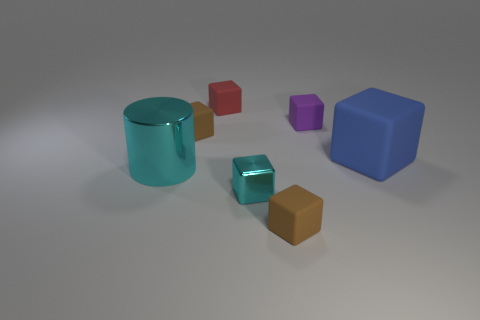How many tiny cyan things are made of the same material as the big cyan thing?
Your response must be concise. 1. Does the big block have the same color as the small rubber block in front of the large metallic object?
Give a very brief answer. No. Are there more big cyan metallic things than blocks?
Your answer should be compact. No. The big cube has what color?
Your answer should be very brief. Blue. There is a big thing that is left of the purple matte thing; does it have the same color as the small metallic cube?
Your answer should be very brief. Yes. What material is the tiny block that is the same color as the cylinder?
Keep it short and to the point. Metal. What number of small things are the same color as the cylinder?
Make the answer very short. 1. There is a brown thing that is right of the red cube; is it the same shape as the red matte thing?
Your response must be concise. Yes. Are there fewer large cyan objects behind the purple cube than tiny cyan shiny things on the left side of the big rubber object?
Provide a succinct answer. Yes. There is a big cylinder in front of the big blue cube; what material is it?
Offer a very short reply. Metal. 